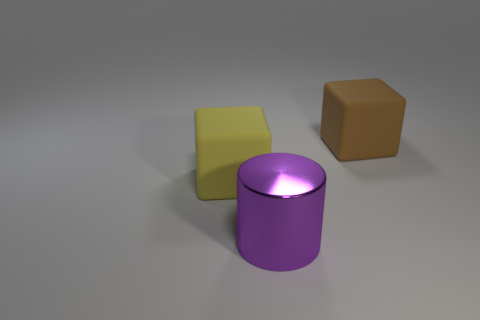Is there a big yellow cube that is to the left of the big matte cube to the left of the large brown block?
Offer a terse response. No. What material is the yellow cube that is the same size as the purple thing?
Provide a succinct answer. Rubber. Are there any brown blocks that have the same size as the cylinder?
Give a very brief answer. Yes. Is the number of cubes the same as the number of shiny blocks?
Provide a succinct answer. No. There is a big cube that is on the left side of the large brown block; what is it made of?
Provide a succinct answer. Rubber. Is the large thing that is in front of the yellow rubber thing made of the same material as the brown thing?
Ensure brevity in your answer.  No. What shape is the yellow object that is the same size as the metallic cylinder?
Your answer should be compact. Cube. How many other big cylinders are the same color as the cylinder?
Offer a terse response. 0. Is the number of brown cubes that are in front of the purple cylinder less than the number of large purple shiny cylinders that are to the right of the big brown rubber thing?
Provide a succinct answer. No. Are there any brown objects in front of the yellow matte thing?
Offer a very short reply. No. 